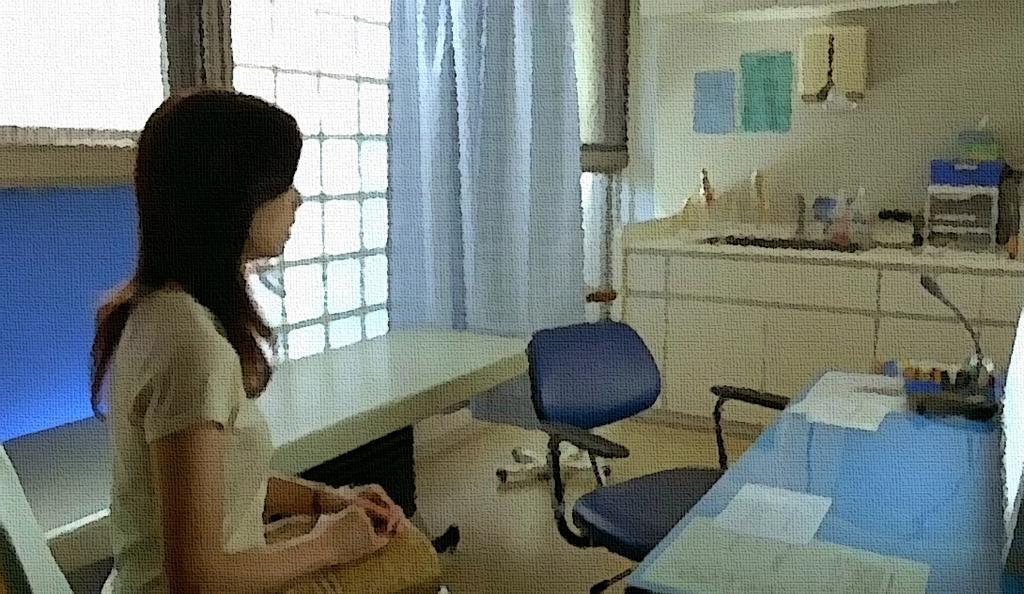Describe this image in one or two sentences. In this image I see a woman who is sitting on the chair and there is chair beside to her, I also see lot of tables and there are few things on it. In the background I see the window, curtain and the wall. 